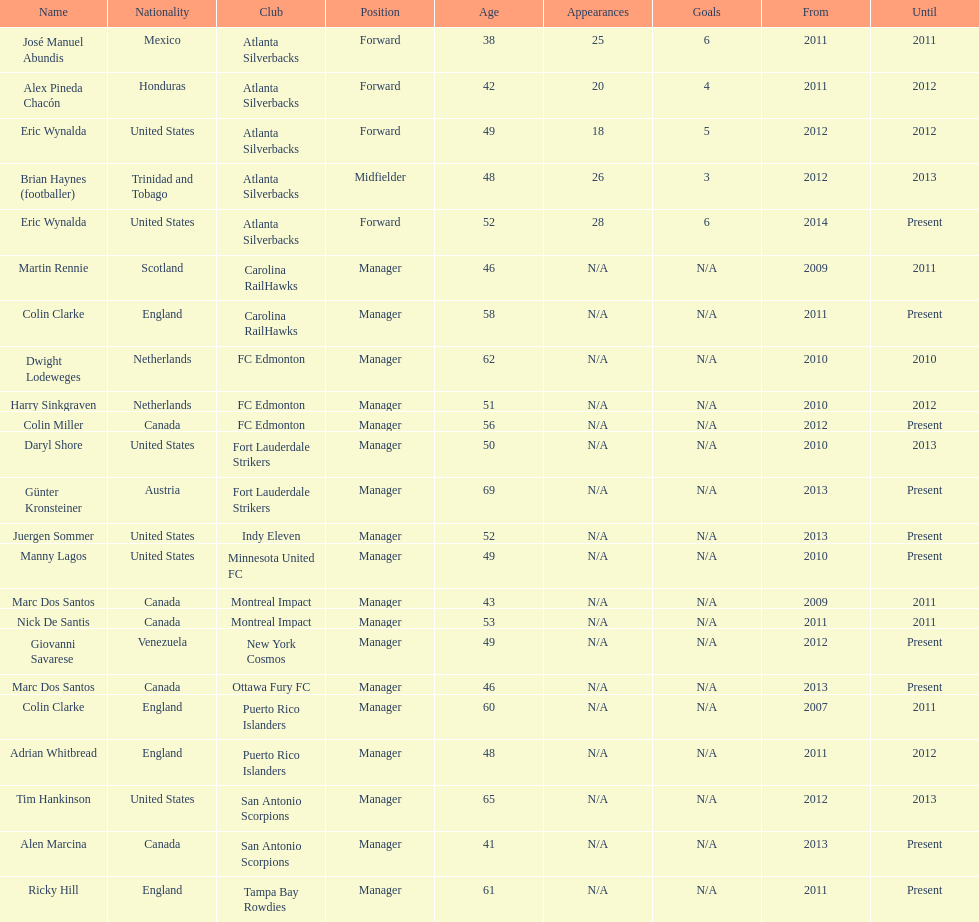What year did marc dos santos start as coach? 2009. Which other starting years correspond with this year? 2009. Who was the other coach with this starting year Martin Rennie. 